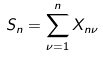<formula> <loc_0><loc_0><loc_500><loc_500>S _ { n } = \sum _ { \nu = 1 } ^ { n } X _ { n \nu }</formula> 